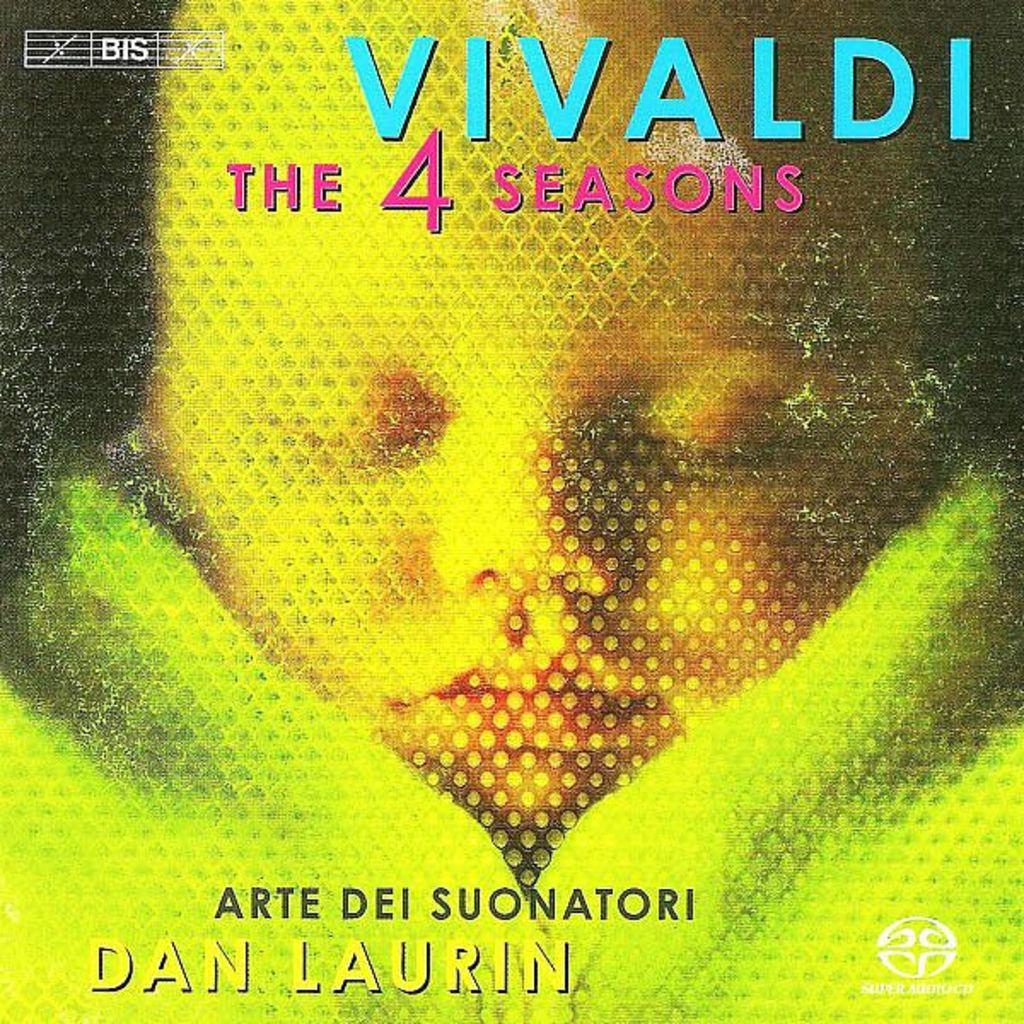Whose name is on this?
Provide a short and direct response. Dan laurin. What is the title?
Provide a succinct answer. Vivaldi. 